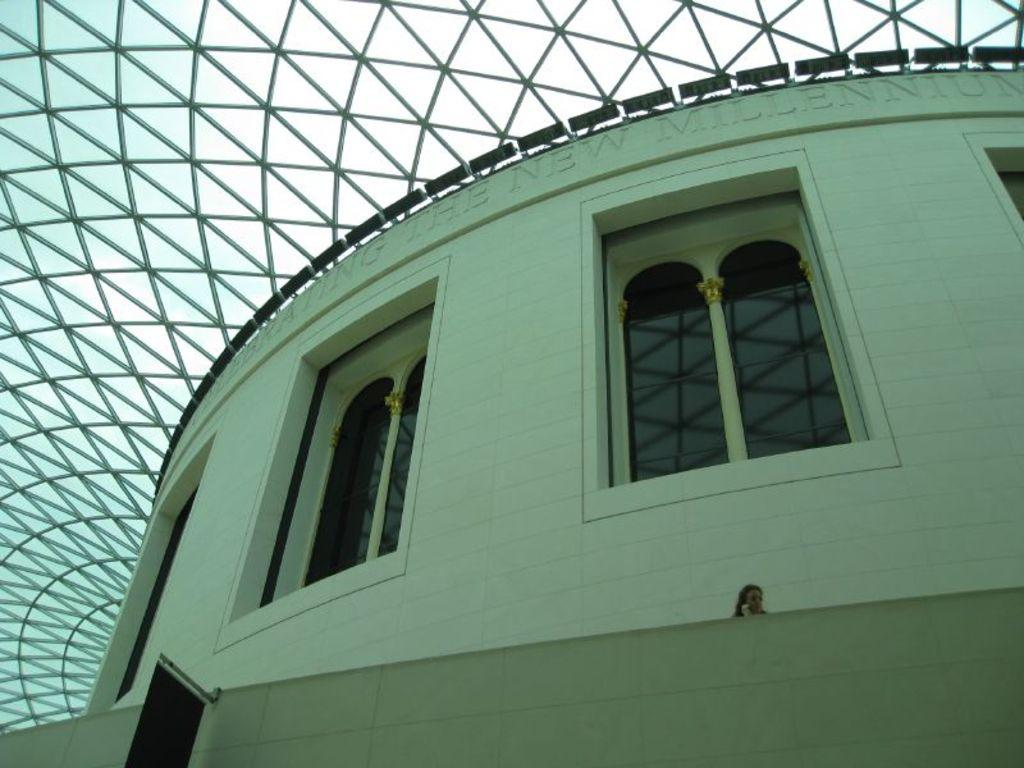What is the main structure in the image? There is a building in the image. What can be seen on the building? There is text written on the building. What feature does the building have? The building has windows. Who or what is present in the image besides the building? There is a person in the image. What is visible at the top of the image? The sky is visible at the top of the image. What can be observed in the sky? There are clouds in the sky. What type of whip is the person holding in the image? There is no whip present in the image; the person is not holding any object. What is the name of the person's dad in the image? There is no information about the person's dad in the image, as it only shows a person standing near a building. 